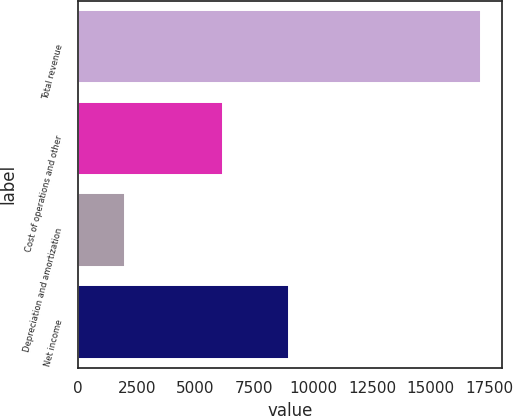<chart> <loc_0><loc_0><loc_500><loc_500><bar_chart><fcel>Total revenue<fcel>Cost of operations and other<fcel>Depreciation and amortization<fcel>Net income<nl><fcel>17154<fcel>6159<fcel>2023<fcel>8972<nl></chart> 